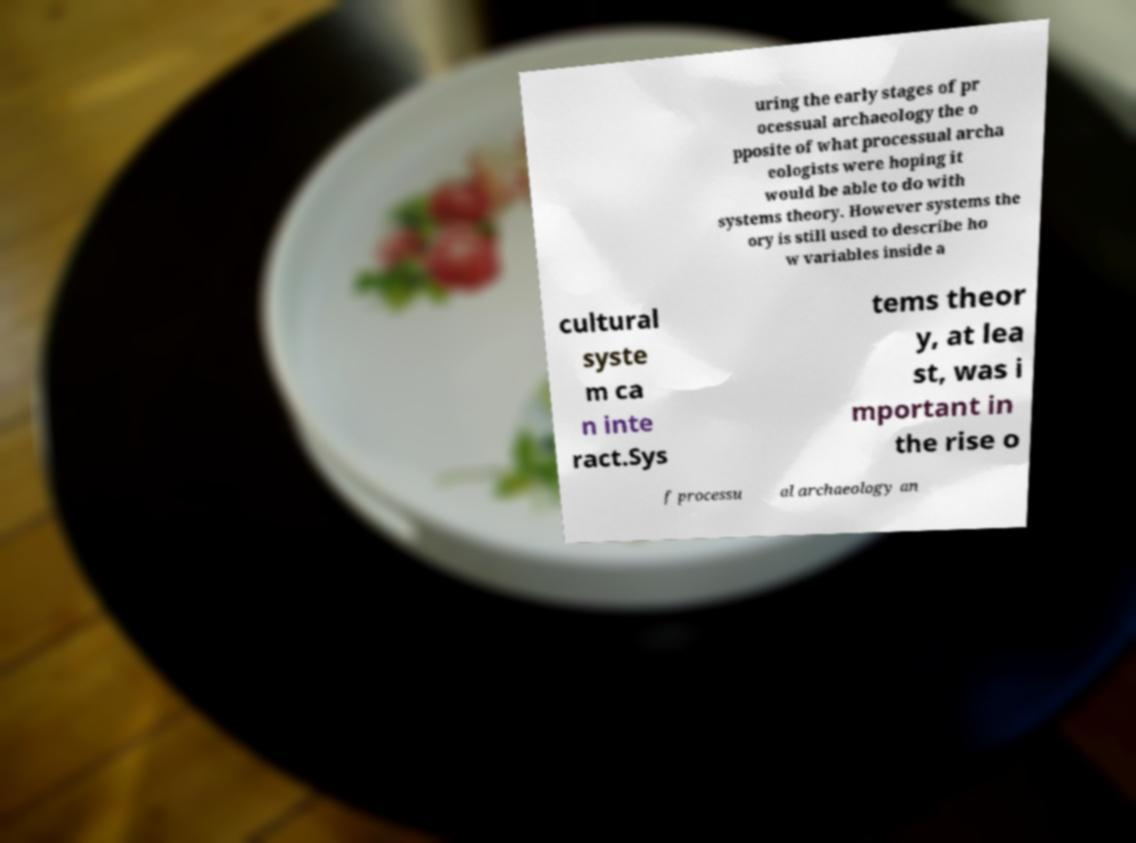Can you read and provide the text displayed in the image?This photo seems to have some interesting text. Can you extract and type it out for me? uring the early stages of pr ocessual archaeology the o pposite of what processual archa eologists were hoping it would be able to do with systems theory. However systems the ory is still used to describe ho w variables inside a cultural syste m ca n inte ract.Sys tems theor y, at lea st, was i mportant in the rise o f processu al archaeology an 